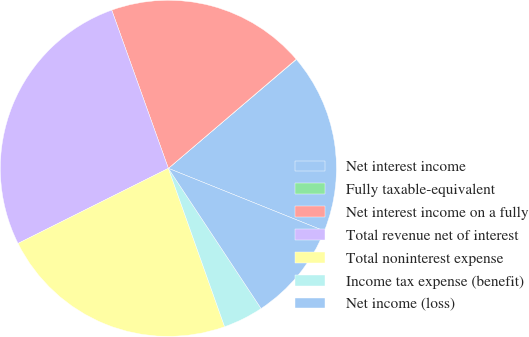Convert chart to OTSL. <chart><loc_0><loc_0><loc_500><loc_500><pie_chart><fcel>Net interest income<fcel>Fully taxable-equivalent<fcel>Net interest income on a fully<fcel>Total revenue net of interest<fcel>Total noninterest expense<fcel>Income tax expense (benefit)<fcel>Net income (loss)<nl><fcel>17.3%<fcel>0.03%<fcel>19.22%<fcel>26.9%<fcel>23.06%<fcel>3.87%<fcel>9.62%<nl></chart> 